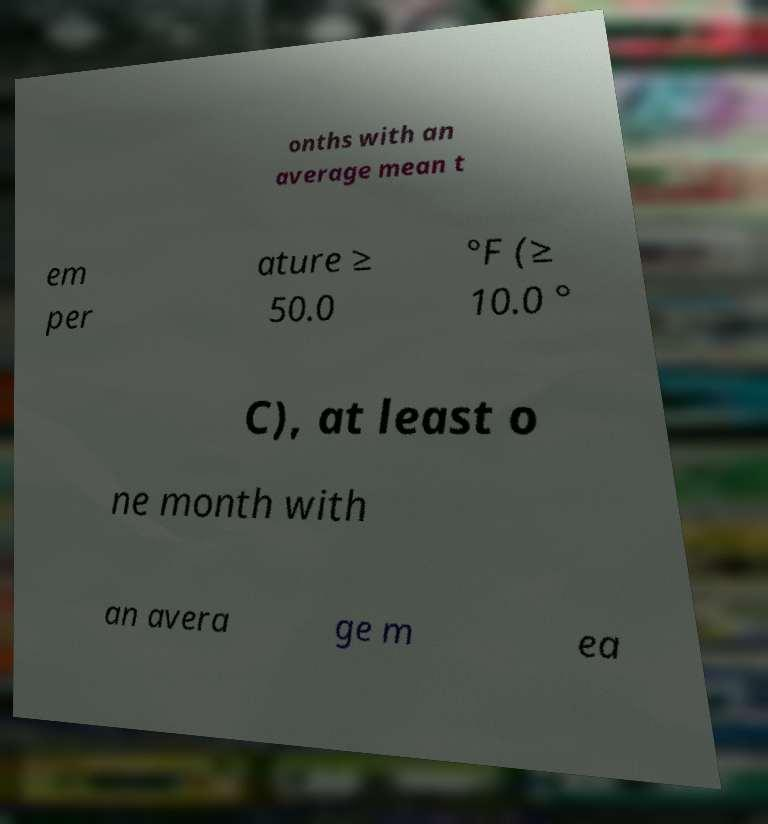Please read and relay the text visible in this image. What does it say? onths with an average mean t em per ature ≥ 50.0 °F (≥ 10.0 ° C), at least o ne month with an avera ge m ea 